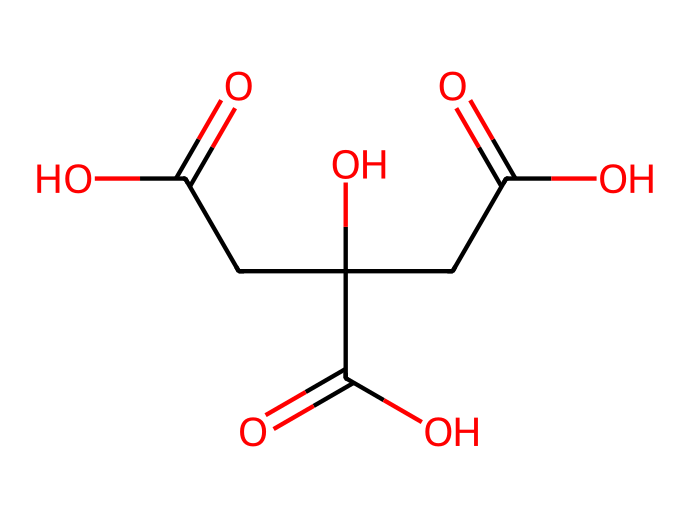What is the common name for this chemical? The given SMILES representation corresponds to a molecule commonly known for its sour taste in foods and used in flavoring and preservation. This structure represents citric acid, which is well-known in the culinary world.
Answer: citric acid How many carboxylic acid groups are present? By analyzing the structure from the SMILES, you can see three instances of the carboxylic acid functional group (−COOH), indicated by the presence of each "C(=O)O" segment. Thus, there are three groups.
Answer: 3 What is the total number of carbon atoms in the structure? To find the total count, you count the carbon atoms represented in the structure from the SMILES notation. The structure shows a total of six carbon atoms in the backbone of citric acid.
Answer: 6 Does this compound exhibit a crystalline structure? Citric acid typically crystallizes due to its molecular arrangement similar to many organic acids, which allows for defined lattice formation when cooled. Thus, it does exhibit a crystalline structure.
Answer: Yes What is a primary function of citric acid in food? Citric acid is primarily used as a natural preservative in food and beverages, which helps increase shelf life and prevent spoilage due to its low pH.
Answer: Preservative What type of solid is citric acid primarily classified as? Citric acid can be classified as an organic acid and is specifically categorized as a crystalline solid because of its molecular arrangement and bonding, which leads to a solid state at room temperature.
Answer: Crystalline solid In how many hydroxyl groups is citric acid composed? In the structural representation of citric acid, there are three -OH (hydroxyl) groups indicated, which contribute to its acidic properties. These are a part of the structure closer to the central carbon atoms.
Answer: 3 